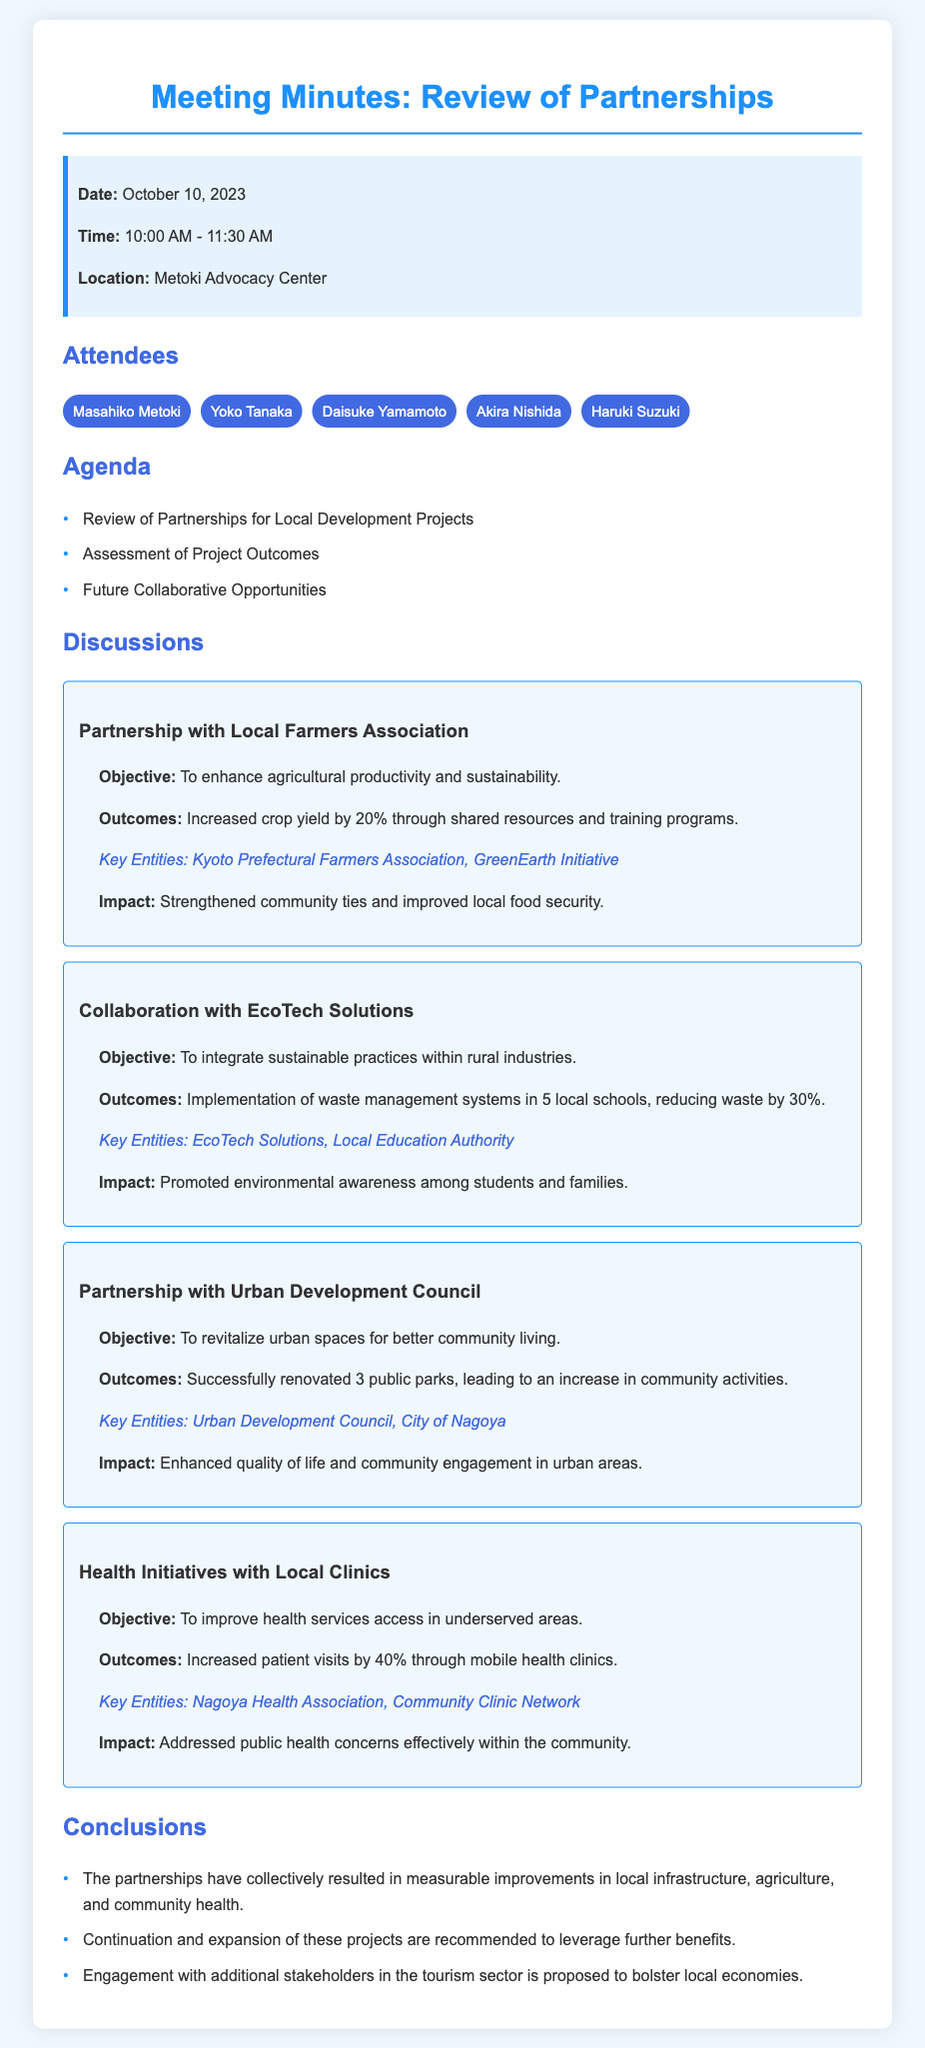What is the date of the meeting? The date of the meeting is stated at the beginning of the document.
Answer: October 10, 2023 Who attended the meeting? A list of attendees is provided in the document.
Answer: Masahiko Metoki, Yoko Tanaka, Daisuke Yamamoto, Akira Nishida, Haruki Suzuki What was the objective of the partnership with the Local Farmers Association? The objective is mentioned in the discussion section for the partnership.
Answer: To enhance agricultural productivity and sustainability How much did crop yield increase through the partnership with the Local Farmers Association? The outcome specifically states the percentage increase in crop yield from the partnership.
Answer: 20% What was a measurable outcome of the collaboration with EcoTech Solutions? This outcome is provided under the discussion of that partnership.
Answer: Reducing waste by 30% What is one of the key entities involved in the partnership with the Urban Development Council? The key entities listed under that partnership's discussion are key to understanding the partnership.
Answer: Urban Development Council How many public parks were renovated through the partnership with the Urban Development Council? The specific number of public parks renovated is included in the discussion section.
Answer: 3 What is one proposed action mentioned in the conclusions? The conclusions section outlines proposed actions for the future of partnerships.
Answer: Engagement with additional stakeholders in the tourism sector What percentage did patient visits increase by through health initiatives with local clinics? The outcome clearly states the percentage increase in patient visits.
Answer: 40% 